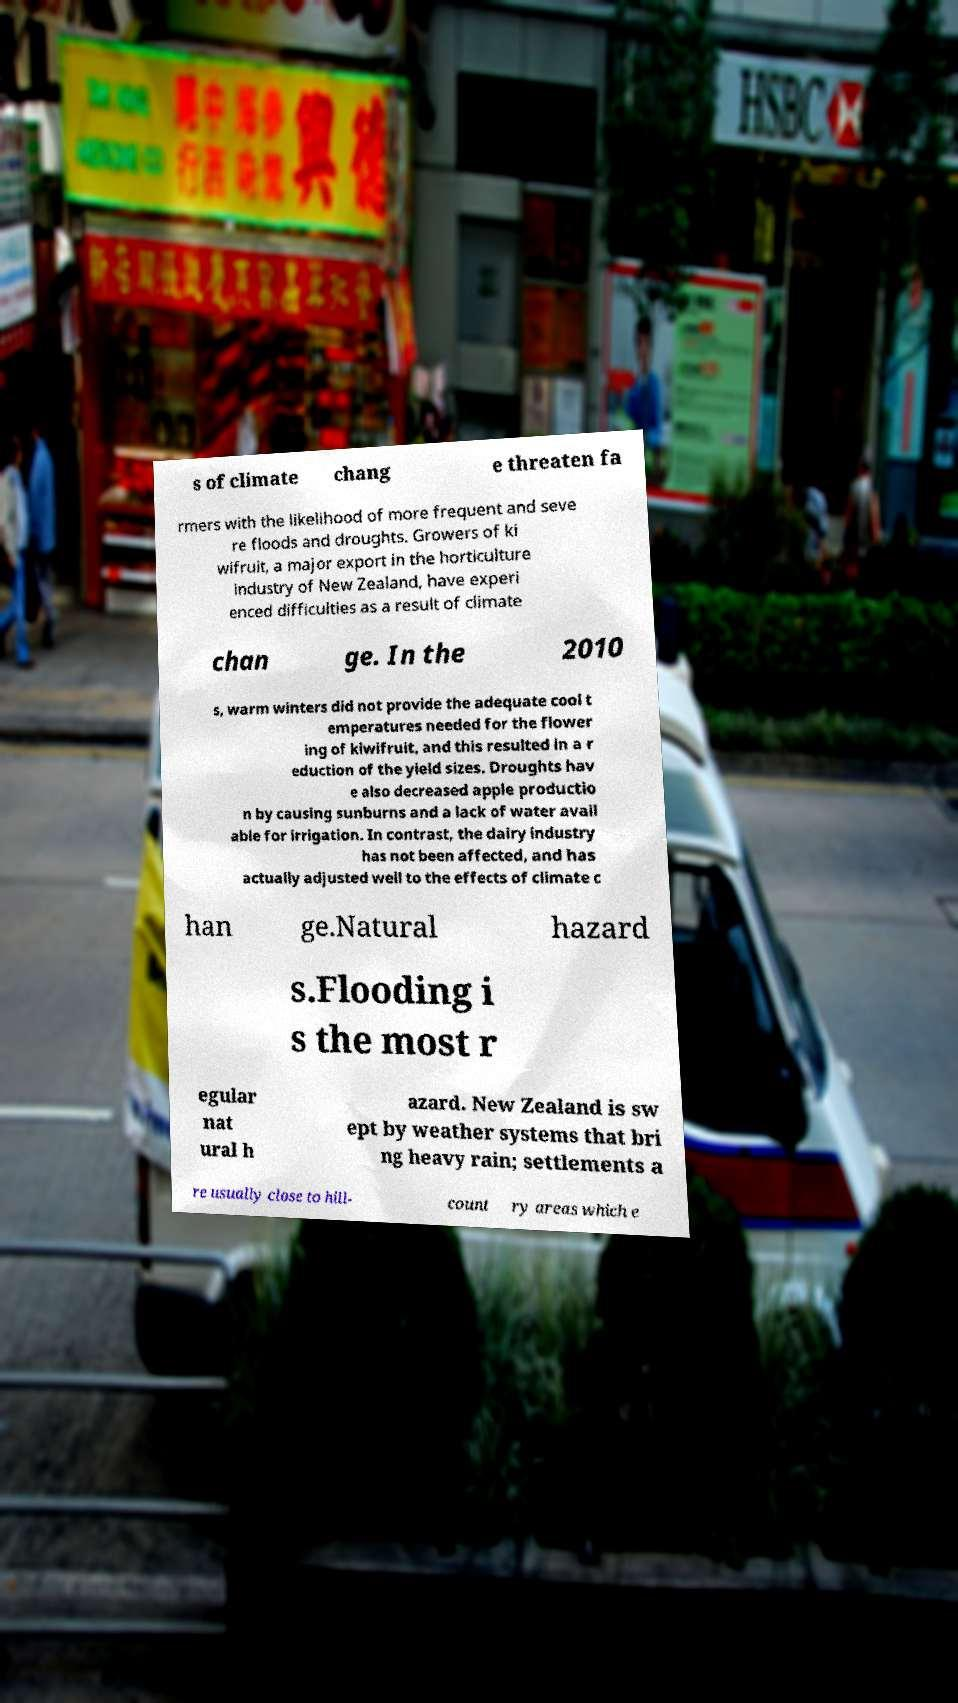Could you extract and type out the text from this image? s of climate chang e threaten fa rmers with the likelihood of more frequent and seve re floods and droughts. Growers of ki wifruit, a major export in the horticulture industry of New Zealand, have experi enced difficulties as a result of climate chan ge. In the 2010 s, warm winters did not provide the adequate cool t emperatures needed for the flower ing of kiwifruit, and this resulted in a r eduction of the yield sizes. Droughts hav e also decreased apple productio n by causing sunburns and a lack of water avail able for irrigation. In contrast, the dairy industry has not been affected, and has actually adjusted well to the effects of climate c han ge.Natural hazard s.Flooding i s the most r egular nat ural h azard. New Zealand is sw ept by weather systems that bri ng heavy rain; settlements a re usually close to hill- count ry areas which e 